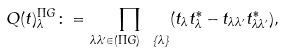Convert formula to latex. <formula><loc_0><loc_0><loc_500><loc_500>Q ( t ) ^ { \Pi G } _ { \lambda } \colon = \prod _ { \lambda \lambda ^ { \prime } \in ( \Pi G ) \ \{ \lambda \} } ( t _ { \lambda } t ^ { * } _ { \lambda } - t _ { \lambda \lambda ^ { \prime } } t ^ { * } _ { \lambda \lambda ^ { \prime } } ) ,</formula> 